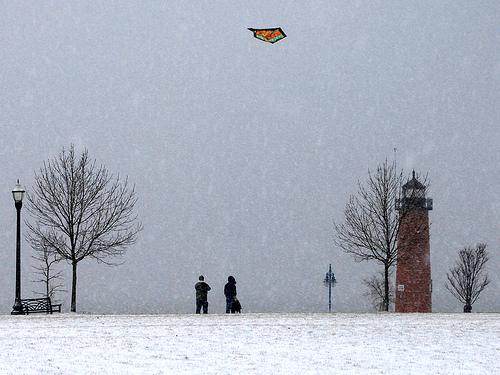Is it daytime?
Give a very brief answer. Yes. Are people flying a kite in the winter?
Quick response, please. Yes. Is it snowing?
Give a very brief answer. Yes. Is this photo in color?
Concise answer only. Yes. 